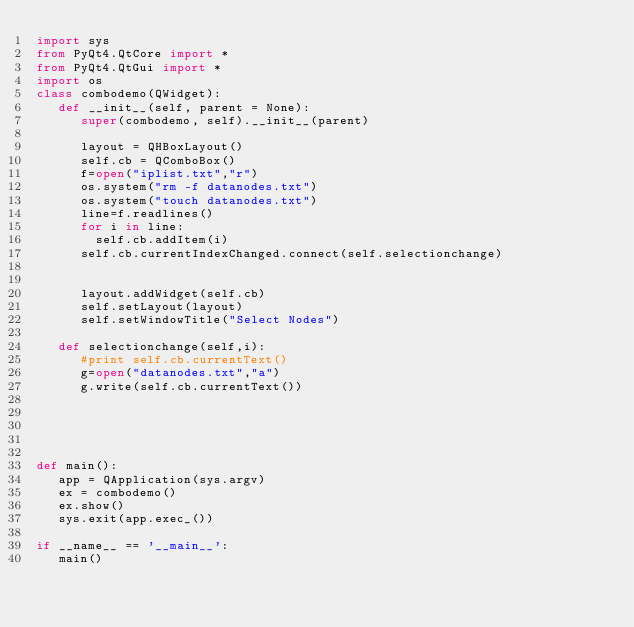Convert code to text. <code><loc_0><loc_0><loc_500><loc_500><_Python_>import sys
from PyQt4.QtCore import *
from PyQt4.QtGui import *
import os
class combodemo(QWidget):
   def __init__(self, parent = None):
      super(combodemo, self).__init__(parent)
      
      layout = QHBoxLayout()
      self.cb = QComboBox()
      f=open("iplist.txt","r")
      os.system("rm -f datanodes.txt")
      os.system("touch datanodes.txt")
      line=f.readlines()
      for i in line:
      	self.cb.addItem(i)
      self.cb.currentIndexChanged.connect(self.selectionchange)
      
      
      layout.addWidget(self.cb)
      self.setLayout(layout)
      self.setWindowTitle("Select Nodes")

   def selectionchange(self,i):
      #print self.cb.currentText()
      g=open("datanodes.txt","a")
      g.write(self.cb.currentText())
      
      
     
      
	   	
def main():
   app = QApplication(sys.argv)
   ex = combodemo()
   ex.show()
   sys.exit(app.exec_())

if __name__ == '__main__':
   main()
</code> 